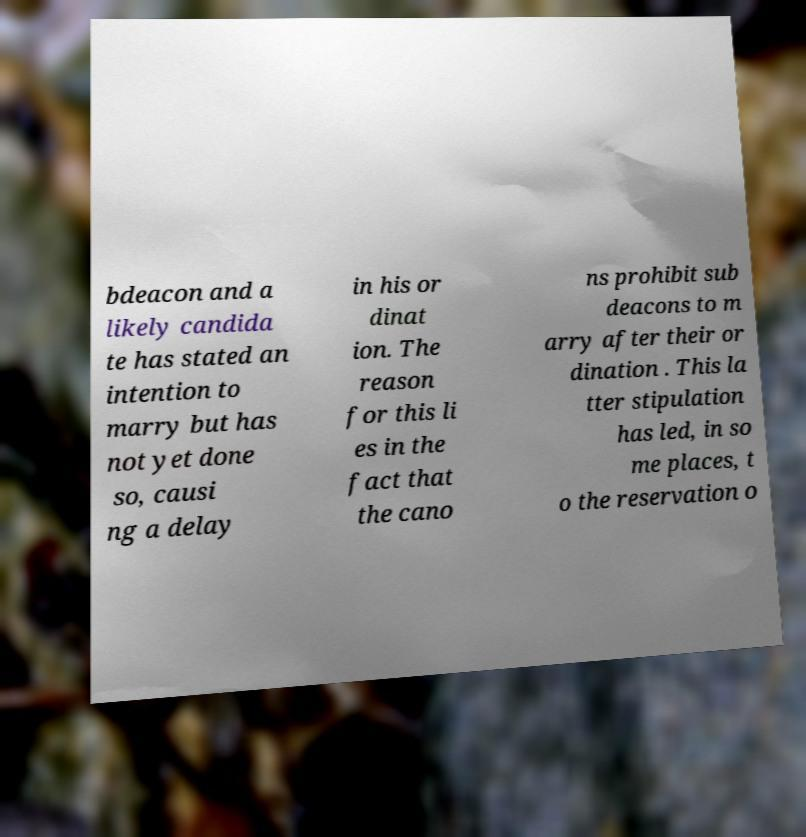Could you extract and type out the text from this image? bdeacon and a likely candida te has stated an intention to marry but has not yet done so, causi ng a delay in his or dinat ion. The reason for this li es in the fact that the cano ns prohibit sub deacons to m arry after their or dination . This la tter stipulation has led, in so me places, t o the reservation o 